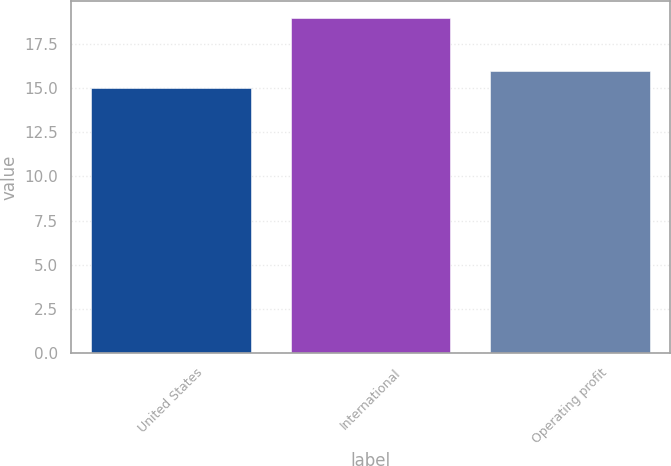<chart> <loc_0><loc_0><loc_500><loc_500><bar_chart><fcel>United States<fcel>International<fcel>Operating profit<nl><fcel>15<fcel>19<fcel>16<nl></chart> 